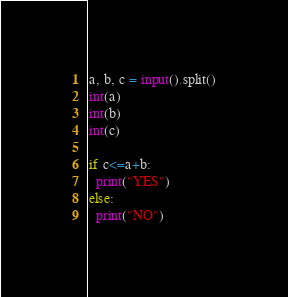Convert code to text. <code><loc_0><loc_0><loc_500><loc_500><_Python_>a, b, c = input().split()
int(a)
int(b)
int(c)

if c<=a+b:
  print("YES")
else:
  print("NO")</code> 